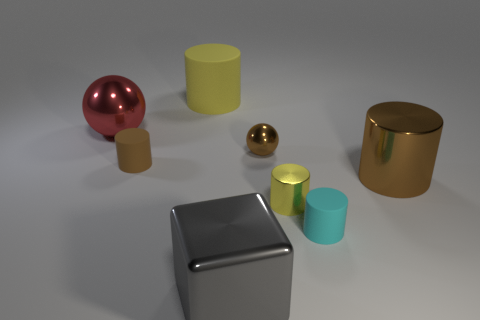What shape is the cyan matte thing that is the same size as the yellow metallic thing?
Ensure brevity in your answer.  Cylinder. What is the shape of the small shiny object that is the same color as the big metal cylinder?
Offer a very short reply. Sphere. What shape is the big gray object that is the same material as the brown ball?
Offer a very short reply. Cube. Is the number of large green rubber things greater than the number of tiny cylinders?
Your response must be concise. No. There is a small brown thing that is the same shape as the red thing; what is its material?
Keep it short and to the point. Metal. Do the big red ball and the big brown cylinder have the same material?
Keep it short and to the point. Yes. Are there more tiny cylinders that are on the right side of the gray object than yellow things?
Offer a terse response. No. What material is the brown cylinder on the left side of the cylinder that is behind the ball that is right of the big yellow matte object?
Offer a terse response. Rubber. What number of objects are large red shiny balls or big things left of the small sphere?
Provide a short and direct response. 3. Do the big thing that is to the right of the tiny cyan object and the block have the same color?
Provide a short and direct response. No. 